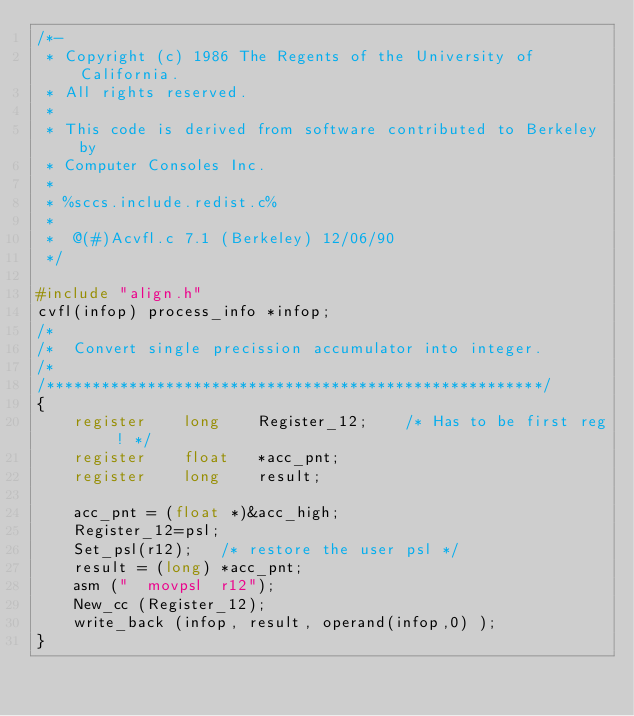Convert code to text. <code><loc_0><loc_0><loc_500><loc_500><_C_>/*-
 * Copyright (c) 1986 The Regents of the University of California.
 * All rights reserved.
 *
 * This code is derived from software contributed to Berkeley by
 * Computer Consoles Inc.
 *
 * %sccs.include.redist.c%
 *
 *	@(#)Acvfl.c	7.1 (Berkeley) 12/06/90
 */

#include "align.h"
cvfl(infop)	process_info *infop;
/*
/*	Convert single precission accumulator into integer.
/*
/******************************************************/
{
	register	long	Register_12;	/* Has to be first reg ! */
	register	float	*acc_pnt;
	register	long	result;

	acc_pnt = (float *)&acc_high;
	Register_12=psl;
	Set_psl(r12);	/* restore the user psl */
	result = (long) *acc_pnt;
	asm ("	movpsl	r12");
	New_cc (Register_12);
	write_back (infop, result, operand(infop,0) );
}
</code> 